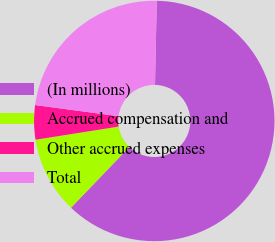Convert chart. <chart><loc_0><loc_0><loc_500><loc_500><pie_chart><fcel>(In millions)<fcel>Accrued compensation and<fcel>Other accrued expenses<fcel>Total<nl><fcel>61.84%<fcel>10.33%<fcel>4.61%<fcel>23.22%<nl></chart> 